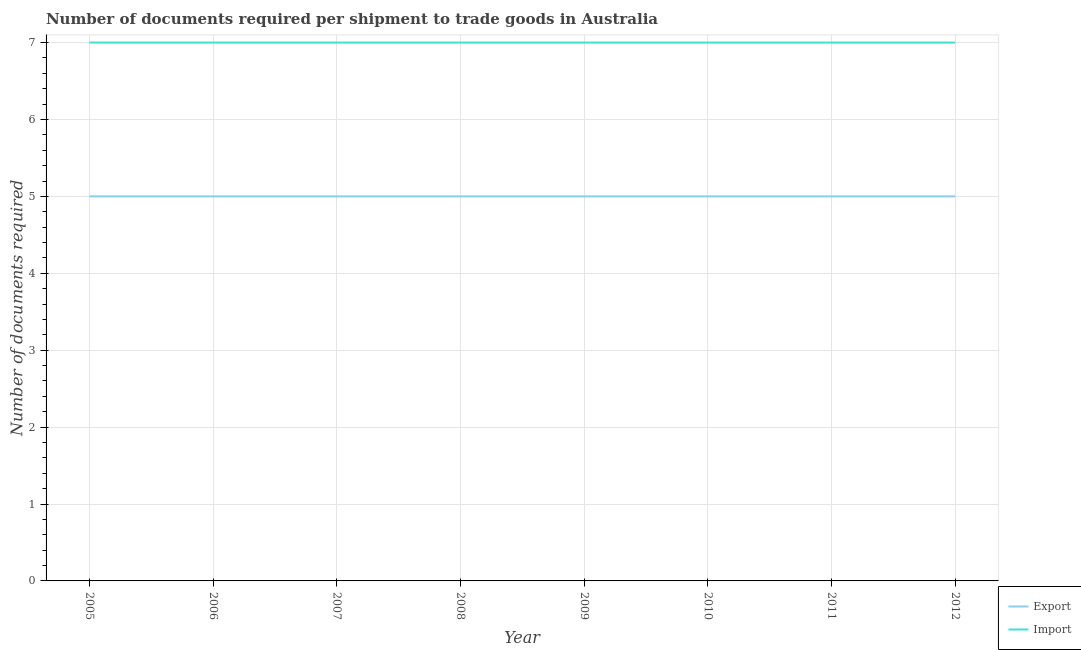Is the number of lines equal to the number of legend labels?
Your answer should be compact. Yes. What is the number of documents required to export goods in 2010?
Provide a succinct answer. 5. Across all years, what is the maximum number of documents required to export goods?
Offer a terse response. 5. Across all years, what is the minimum number of documents required to export goods?
Keep it short and to the point. 5. In which year was the number of documents required to import goods maximum?
Provide a short and direct response. 2005. What is the total number of documents required to import goods in the graph?
Your response must be concise. 56. What is the difference between the number of documents required to import goods in 2006 and that in 2012?
Ensure brevity in your answer.  0. What is the difference between the number of documents required to export goods in 2012 and the number of documents required to import goods in 2011?
Offer a terse response. -2. In the year 2012, what is the difference between the number of documents required to import goods and number of documents required to export goods?
Your answer should be very brief. 2. What is the ratio of the number of documents required to export goods in 2005 to that in 2006?
Ensure brevity in your answer.  1. Is the difference between the number of documents required to import goods in 2006 and 2007 greater than the difference between the number of documents required to export goods in 2006 and 2007?
Ensure brevity in your answer.  No. In how many years, is the number of documents required to import goods greater than the average number of documents required to import goods taken over all years?
Offer a very short reply. 0. Is the sum of the number of documents required to export goods in 2006 and 2010 greater than the maximum number of documents required to import goods across all years?
Ensure brevity in your answer.  Yes. Is the number of documents required to import goods strictly greater than the number of documents required to export goods over the years?
Offer a terse response. Yes. What is the difference between two consecutive major ticks on the Y-axis?
Keep it short and to the point. 1. Does the graph contain grids?
Provide a succinct answer. Yes. How are the legend labels stacked?
Offer a very short reply. Vertical. What is the title of the graph?
Make the answer very short. Number of documents required per shipment to trade goods in Australia. What is the label or title of the Y-axis?
Provide a short and direct response. Number of documents required. What is the Number of documents required of Export in 2005?
Keep it short and to the point. 5. What is the Number of documents required of Import in 2006?
Offer a terse response. 7. What is the Number of documents required in Import in 2007?
Provide a succinct answer. 7. What is the Number of documents required in Export in 2008?
Provide a succinct answer. 5. What is the Number of documents required in Import in 2008?
Provide a short and direct response. 7. What is the Number of documents required of Export in 2009?
Keep it short and to the point. 5. What is the Number of documents required of Import in 2009?
Give a very brief answer. 7. What is the Number of documents required in Export in 2010?
Ensure brevity in your answer.  5. What is the Number of documents required in Export in 2011?
Make the answer very short. 5. What is the Number of documents required of Import in 2011?
Offer a terse response. 7. What is the Number of documents required in Import in 2012?
Offer a terse response. 7. Across all years, what is the minimum Number of documents required of Export?
Offer a terse response. 5. Across all years, what is the minimum Number of documents required of Import?
Make the answer very short. 7. What is the difference between the Number of documents required of Import in 2005 and that in 2006?
Offer a terse response. 0. What is the difference between the Number of documents required in Import in 2005 and that in 2007?
Provide a short and direct response. 0. What is the difference between the Number of documents required in Export in 2005 and that in 2008?
Your response must be concise. 0. What is the difference between the Number of documents required in Import in 2005 and that in 2008?
Your answer should be very brief. 0. What is the difference between the Number of documents required of Import in 2005 and that in 2009?
Give a very brief answer. 0. What is the difference between the Number of documents required in Export in 2005 and that in 2011?
Provide a succinct answer. 0. What is the difference between the Number of documents required of Import in 2006 and that in 2007?
Ensure brevity in your answer.  0. What is the difference between the Number of documents required in Import in 2006 and that in 2008?
Ensure brevity in your answer.  0. What is the difference between the Number of documents required of Import in 2006 and that in 2009?
Offer a terse response. 0. What is the difference between the Number of documents required of Export in 2006 and that in 2011?
Make the answer very short. 0. What is the difference between the Number of documents required of Import in 2006 and that in 2011?
Offer a terse response. 0. What is the difference between the Number of documents required in Export in 2006 and that in 2012?
Your answer should be very brief. 0. What is the difference between the Number of documents required in Export in 2007 and that in 2009?
Give a very brief answer. 0. What is the difference between the Number of documents required of Export in 2007 and that in 2010?
Keep it short and to the point. 0. What is the difference between the Number of documents required in Import in 2007 and that in 2010?
Ensure brevity in your answer.  0. What is the difference between the Number of documents required of Export in 2007 and that in 2012?
Provide a succinct answer. 0. What is the difference between the Number of documents required of Import in 2008 and that in 2009?
Keep it short and to the point. 0. What is the difference between the Number of documents required of Export in 2008 and that in 2010?
Provide a short and direct response. 0. What is the difference between the Number of documents required in Import in 2008 and that in 2010?
Your response must be concise. 0. What is the difference between the Number of documents required of Export in 2008 and that in 2011?
Make the answer very short. 0. What is the difference between the Number of documents required of Import in 2008 and that in 2011?
Ensure brevity in your answer.  0. What is the difference between the Number of documents required of Export in 2008 and that in 2012?
Provide a succinct answer. 0. What is the difference between the Number of documents required in Export in 2009 and that in 2010?
Your answer should be very brief. 0. What is the difference between the Number of documents required of Export in 2009 and that in 2012?
Give a very brief answer. 0. What is the difference between the Number of documents required in Import in 2009 and that in 2012?
Give a very brief answer. 0. What is the difference between the Number of documents required of Import in 2010 and that in 2011?
Ensure brevity in your answer.  0. What is the difference between the Number of documents required in Export in 2010 and that in 2012?
Your response must be concise. 0. What is the difference between the Number of documents required of Export in 2011 and that in 2012?
Provide a short and direct response. 0. What is the difference between the Number of documents required of Export in 2005 and the Number of documents required of Import in 2006?
Give a very brief answer. -2. What is the difference between the Number of documents required in Export in 2005 and the Number of documents required in Import in 2011?
Provide a succinct answer. -2. What is the difference between the Number of documents required in Export in 2005 and the Number of documents required in Import in 2012?
Provide a succinct answer. -2. What is the difference between the Number of documents required in Export in 2006 and the Number of documents required in Import in 2008?
Give a very brief answer. -2. What is the difference between the Number of documents required in Export in 2006 and the Number of documents required in Import in 2009?
Make the answer very short. -2. What is the difference between the Number of documents required of Export in 2007 and the Number of documents required of Import in 2008?
Your answer should be very brief. -2. What is the difference between the Number of documents required in Export in 2008 and the Number of documents required in Import in 2010?
Provide a succinct answer. -2. What is the difference between the Number of documents required in Export in 2008 and the Number of documents required in Import in 2011?
Make the answer very short. -2. What is the difference between the Number of documents required of Export in 2008 and the Number of documents required of Import in 2012?
Your answer should be compact. -2. What is the difference between the Number of documents required in Export in 2009 and the Number of documents required in Import in 2011?
Give a very brief answer. -2. What is the difference between the Number of documents required in Export in 2010 and the Number of documents required in Import in 2012?
Provide a short and direct response. -2. In the year 2006, what is the difference between the Number of documents required of Export and Number of documents required of Import?
Offer a very short reply. -2. In the year 2010, what is the difference between the Number of documents required in Export and Number of documents required in Import?
Your answer should be compact. -2. In the year 2011, what is the difference between the Number of documents required in Export and Number of documents required in Import?
Provide a short and direct response. -2. In the year 2012, what is the difference between the Number of documents required of Export and Number of documents required of Import?
Your answer should be very brief. -2. What is the ratio of the Number of documents required of Export in 2005 to that in 2006?
Offer a terse response. 1. What is the ratio of the Number of documents required in Import in 2005 to that in 2007?
Offer a very short reply. 1. What is the ratio of the Number of documents required of Import in 2005 to that in 2008?
Make the answer very short. 1. What is the ratio of the Number of documents required in Export in 2005 to that in 2009?
Your answer should be very brief. 1. What is the ratio of the Number of documents required in Import in 2005 to that in 2009?
Give a very brief answer. 1. What is the ratio of the Number of documents required of Import in 2005 to that in 2011?
Ensure brevity in your answer.  1. What is the ratio of the Number of documents required in Export in 2005 to that in 2012?
Offer a terse response. 1. What is the ratio of the Number of documents required of Import in 2006 to that in 2007?
Provide a short and direct response. 1. What is the ratio of the Number of documents required in Export in 2006 to that in 2008?
Make the answer very short. 1. What is the ratio of the Number of documents required in Import in 2006 to that in 2008?
Your response must be concise. 1. What is the ratio of the Number of documents required in Import in 2006 to that in 2009?
Provide a short and direct response. 1. What is the ratio of the Number of documents required of Export in 2006 to that in 2010?
Provide a short and direct response. 1. What is the ratio of the Number of documents required of Import in 2006 to that in 2010?
Your response must be concise. 1. What is the ratio of the Number of documents required in Export in 2006 to that in 2012?
Keep it short and to the point. 1. What is the ratio of the Number of documents required in Import in 2006 to that in 2012?
Your answer should be very brief. 1. What is the ratio of the Number of documents required of Export in 2007 to that in 2008?
Offer a very short reply. 1. What is the ratio of the Number of documents required in Import in 2007 to that in 2009?
Your answer should be very brief. 1. What is the ratio of the Number of documents required of Export in 2007 to that in 2010?
Your answer should be very brief. 1. What is the ratio of the Number of documents required in Export in 2007 to that in 2011?
Your answer should be compact. 1. What is the ratio of the Number of documents required in Import in 2007 to that in 2011?
Ensure brevity in your answer.  1. What is the ratio of the Number of documents required in Import in 2007 to that in 2012?
Your answer should be very brief. 1. What is the ratio of the Number of documents required of Import in 2008 to that in 2009?
Offer a terse response. 1. What is the ratio of the Number of documents required in Import in 2008 to that in 2010?
Give a very brief answer. 1. What is the ratio of the Number of documents required of Import in 2008 to that in 2011?
Your response must be concise. 1. What is the ratio of the Number of documents required in Import in 2008 to that in 2012?
Make the answer very short. 1. What is the ratio of the Number of documents required in Export in 2009 to that in 2011?
Make the answer very short. 1. What is the ratio of the Number of documents required in Import in 2009 to that in 2011?
Ensure brevity in your answer.  1. What is the ratio of the Number of documents required in Export in 2009 to that in 2012?
Provide a short and direct response. 1. What is the ratio of the Number of documents required in Import in 2010 to that in 2011?
Your answer should be very brief. 1. What is the ratio of the Number of documents required in Export in 2010 to that in 2012?
Your answer should be compact. 1. What is the difference between the highest and the second highest Number of documents required in Import?
Provide a short and direct response. 0. What is the difference between the highest and the lowest Number of documents required of Export?
Ensure brevity in your answer.  0. 